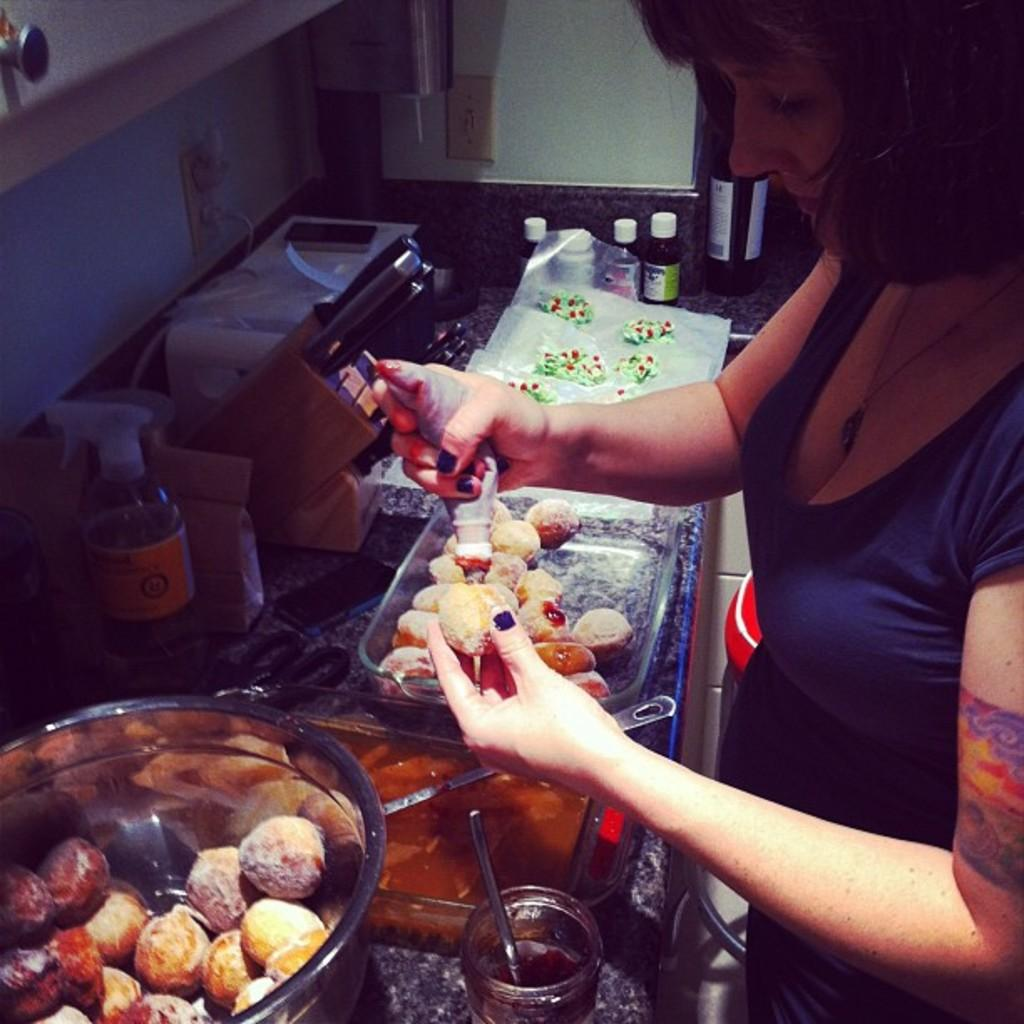What is the woman doing in the image? The woman is holding an object in the image. What can be found in the container in the image? There are food items in a container in the image. What else is present in the image besides the woman and the container? There are bottles in the image. How many airplanes can be seen flying in the image? There are no airplanes visible in the image. What type of cars are parked near the woman in the image? There are no cars present in the image. 